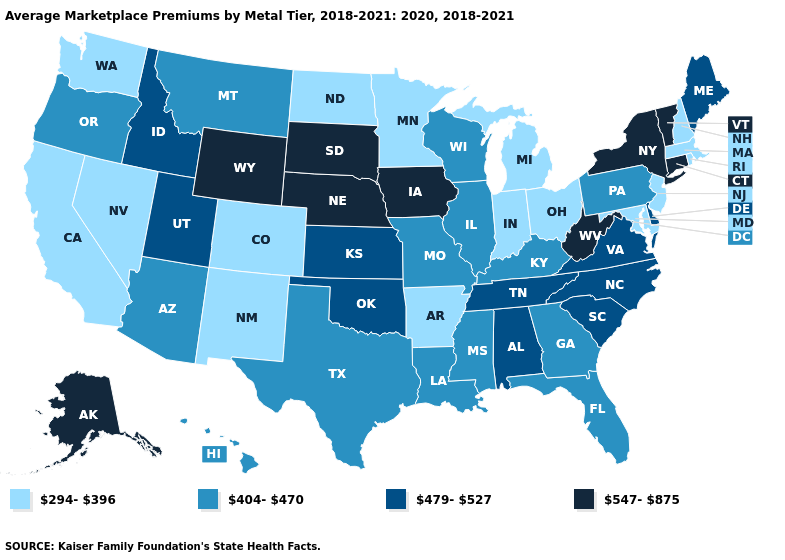Does the map have missing data?
Give a very brief answer. No. What is the highest value in states that border Montana?
Keep it brief. 547-875. What is the lowest value in the MidWest?
Short answer required. 294-396. Does the map have missing data?
Give a very brief answer. No. What is the highest value in states that border Virginia?
Keep it brief. 547-875. Is the legend a continuous bar?
Write a very short answer. No. Among the states that border Tennessee , which have the lowest value?
Keep it brief. Arkansas. What is the value of North Dakota?
Quick response, please. 294-396. Which states have the lowest value in the MidWest?
Keep it brief. Indiana, Michigan, Minnesota, North Dakota, Ohio. Does Montana have the lowest value in the USA?
Give a very brief answer. No. Which states have the lowest value in the USA?
Concise answer only. Arkansas, California, Colorado, Indiana, Maryland, Massachusetts, Michigan, Minnesota, Nevada, New Hampshire, New Jersey, New Mexico, North Dakota, Ohio, Rhode Island, Washington. Which states have the lowest value in the West?
Short answer required. California, Colorado, Nevada, New Mexico, Washington. What is the value of Vermont?
Keep it brief. 547-875. Does the map have missing data?
Concise answer only. No. Which states have the lowest value in the West?
Concise answer only. California, Colorado, Nevada, New Mexico, Washington. 